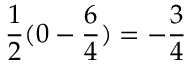Convert formula to latex. <formula><loc_0><loc_0><loc_500><loc_500>{ \frac { 1 } { 2 } } ( 0 - { \frac { 6 } { 4 } } ) = - { \frac { 3 } { 4 } }</formula> 